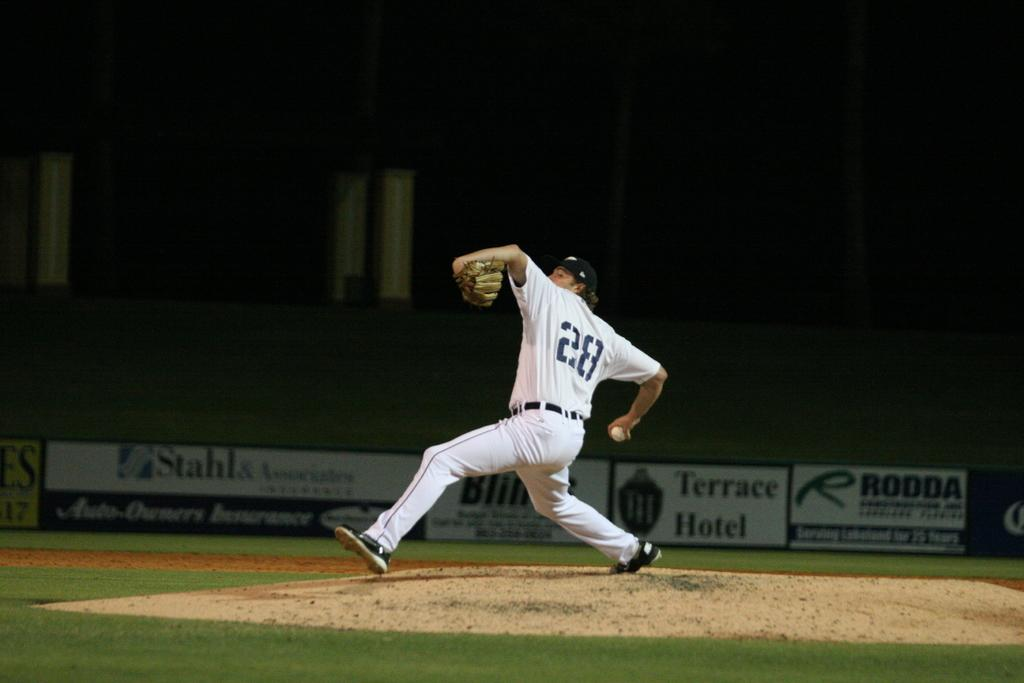<image>
Relay a brief, clear account of the picture shown. a player that h\as the number 28 on the back of their jersey 